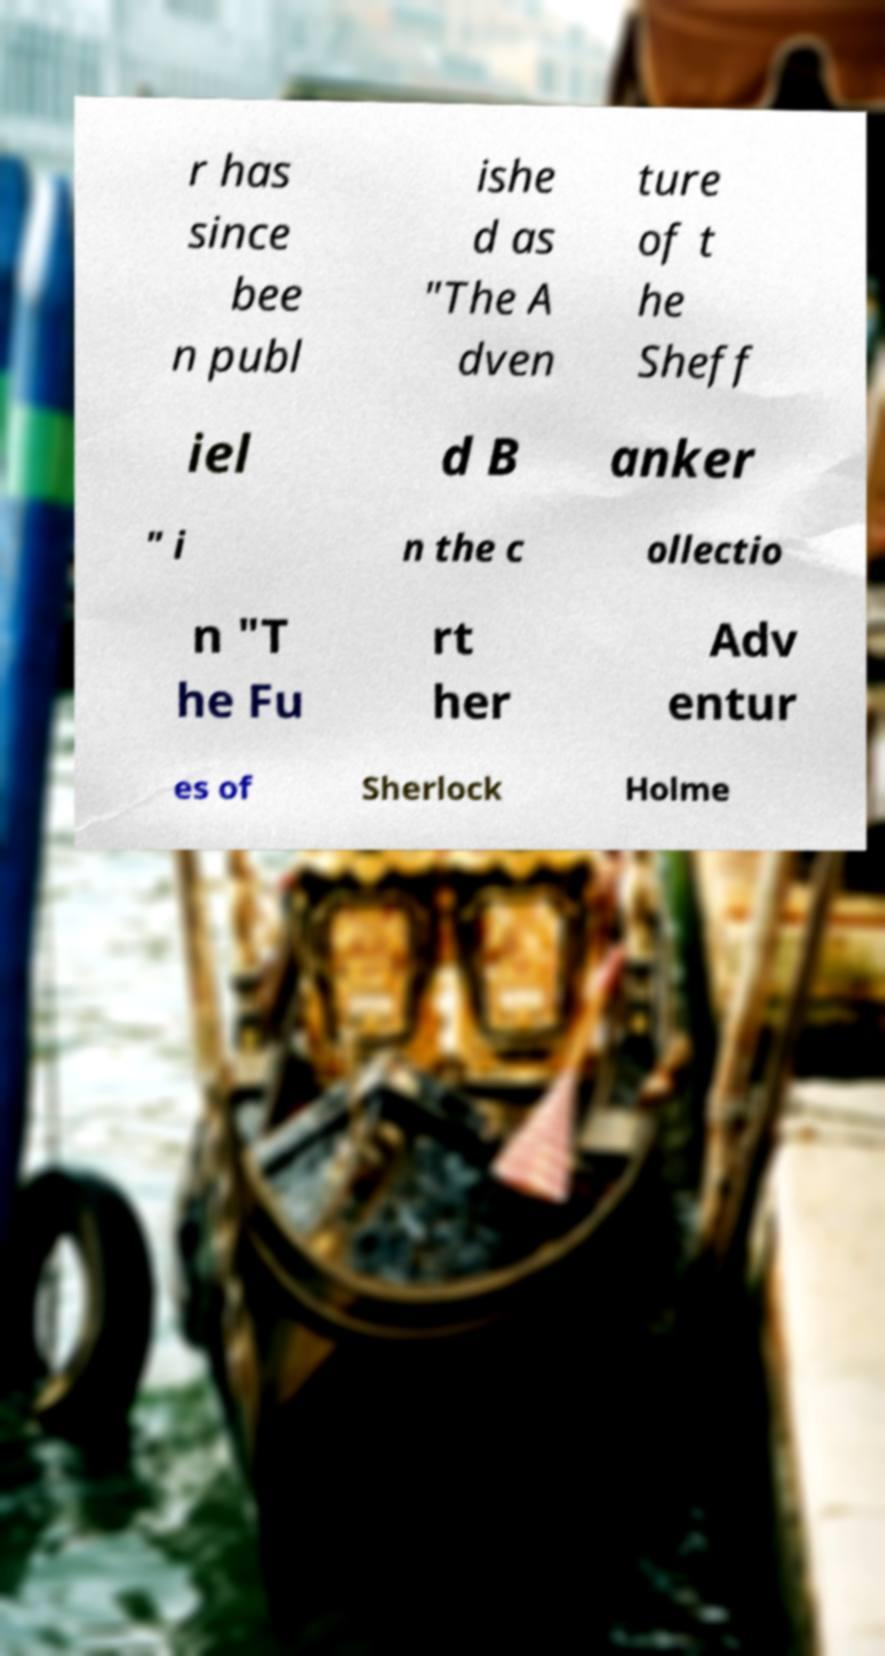For documentation purposes, I need the text within this image transcribed. Could you provide that? r has since bee n publ ishe d as "The A dven ture of t he Sheff iel d B anker " i n the c ollectio n "T he Fu rt her Adv entur es of Sherlock Holme 